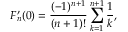<formula> <loc_0><loc_0><loc_500><loc_500>F _ { n } ^ { \prime } ( 0 ) = \frac { ( - 1 ) ^ { n + 1 } } { ( n + 1 ) ! } \sum _ { k = 1 } ^ { n + 1 } \frac { 1 } { k } ,</formula> 